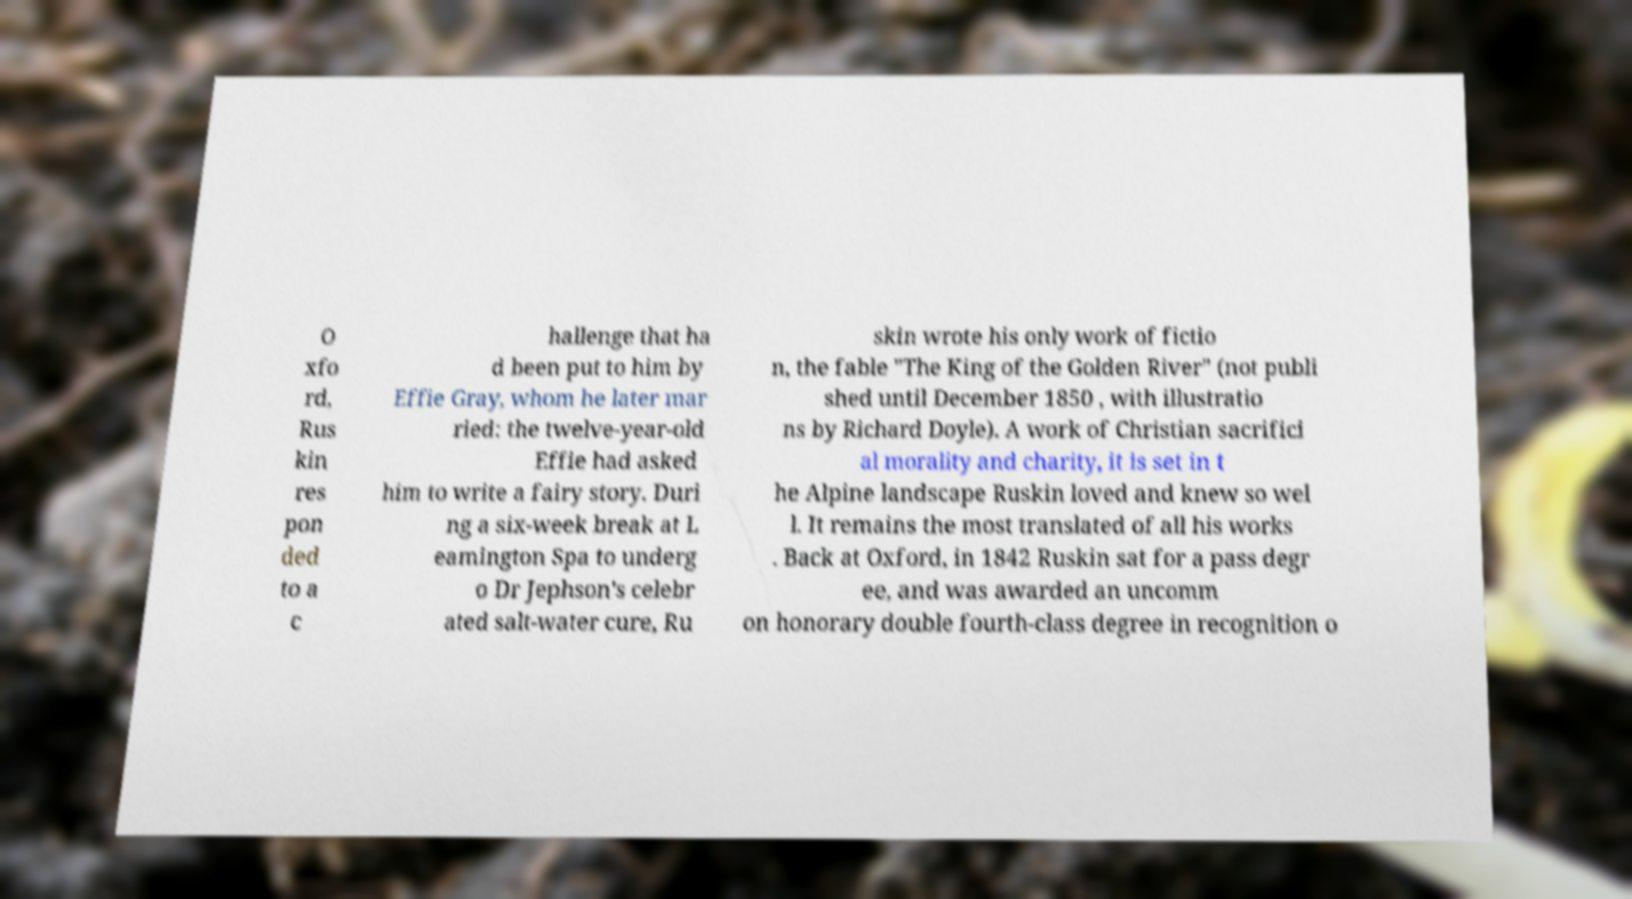Can you accurately transcribe the text from the provided image for me? O xfo rd, Rus kin res pon ded to a c hallenge that ha d been put to him by Effie Gray, whom he later mar ried: the twelve-year-old Effie had asked him to write a fairy story. Duri ng a six-week break at L eamington Spa to underg o Dr Jephson's celebr ated salt-water cure, Ru skin wrote his only work of fictio n, the fable "The King of the Golden River" (not publi shed until December 1850 , with illustratio ns by Richard Doyle). A work of Christian sacrifici al morality and charity, it is set in t he Alpine landscape Ruskin loved and knew so wel l. It remains the most translated of all his works . Back at Oxford, in 1842 Ruskin sat for a pass degr ee, and was awarded an uncomm on honorary double fourth-class degree in recognition o 